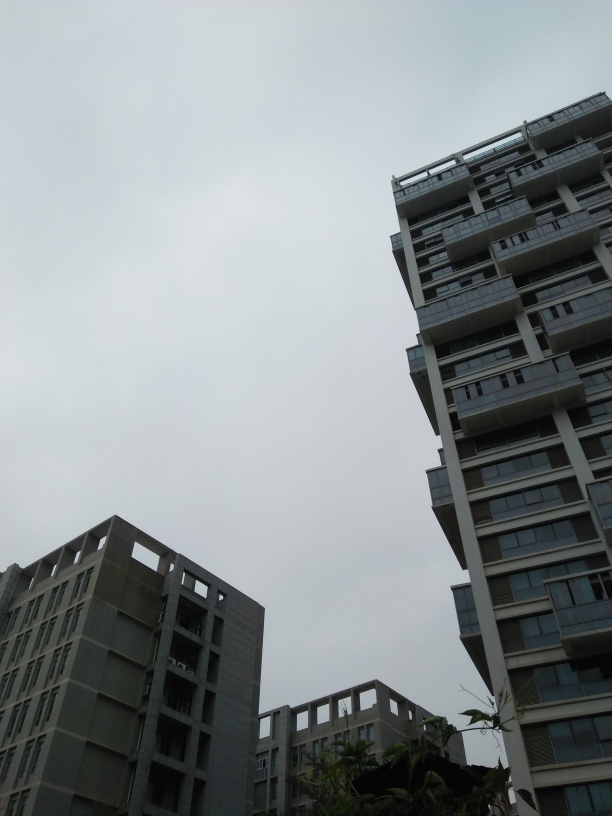Can you tell me about the architectural style of the buildings in this image? The buildings exhibit modern architectural styles with minimalist aesthetics. They feature clean lines, geometric shapes, and a mix of what appears to be concrete and glass materials. The prominent use of balconies and terraces adds to the contemporary urban feel. 